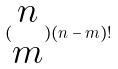Convert formula to latex. <formula><loc_0><loc_0><loc_500><loc_500>( \begin{matrix} n \\ m \end{matrix} ) ( n - m ) !</formula> 